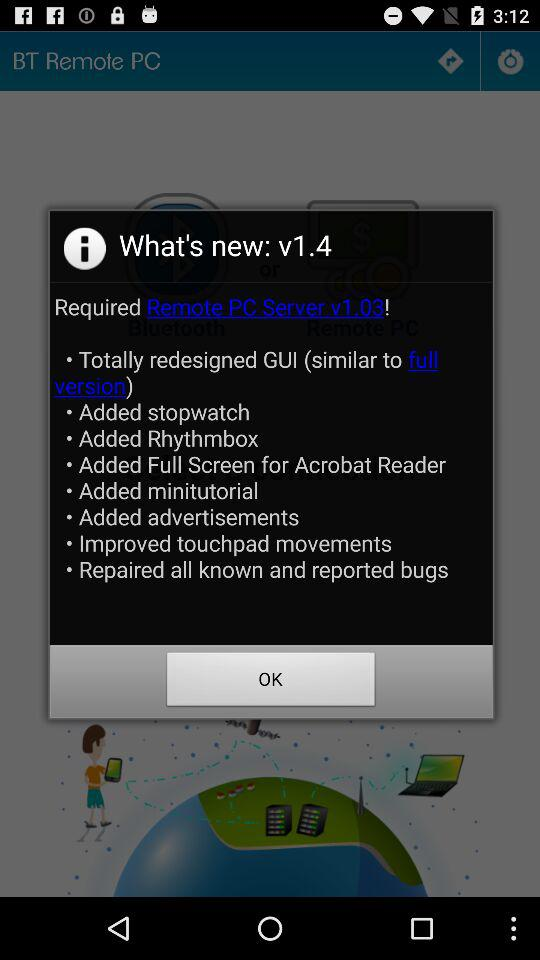What are the new features added? The new features are "Totally redesigned GUI (similar to full version)", "Added stopwatch", "Added Rhythmbox", "Added Full Screen for Acrobat Reader", "Added minitutorial", "Added advertisements", "Improved touchpad movements" and "Repaired all known and reported bugs". 